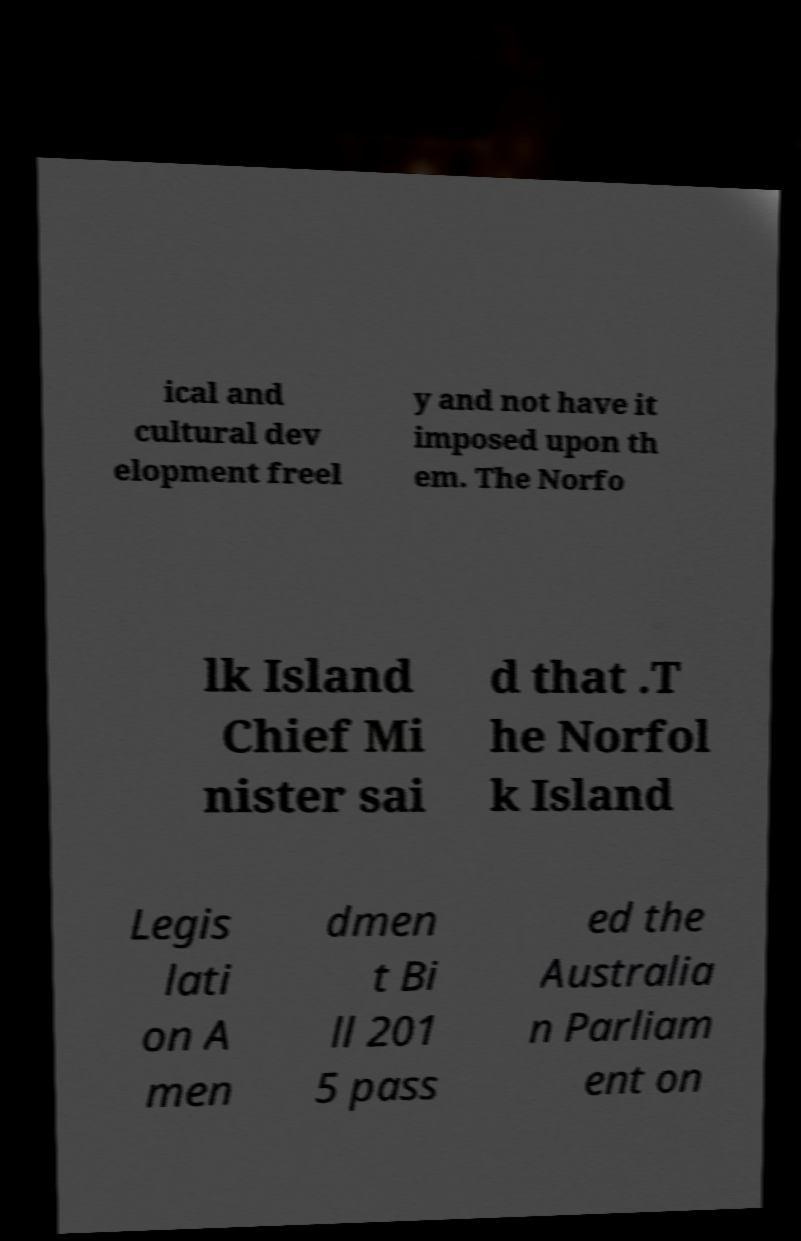Please read and relay the text visible in this image. What does it say? ical and cultural dev elopment freel y and not have it imposed upon th em. The Norfo lk Island Chief Mi nister sai d that .T he Norfol k Island Legis lati on A men dmen t Bi ll 201 5 pass ed the Australia n Parliam ent on 